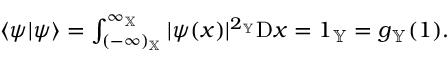<formula> <loc_0><loc_0><loc_500><loc_500>\begin{array} { r } { \langle \psi | \psi \rangle = \int _ { ( - \infty ) _ { \mathbb { X } } } ^ { \infty _ { \mathbb { X } } } | \psi ( x ) | ^ { 2 _ { \mathbb { Y } } } { D } x = 1 _ { \mathbb { Y } } = g _ { \mathbb { Y } } ( 1 ) . } \end{array}</formula> 